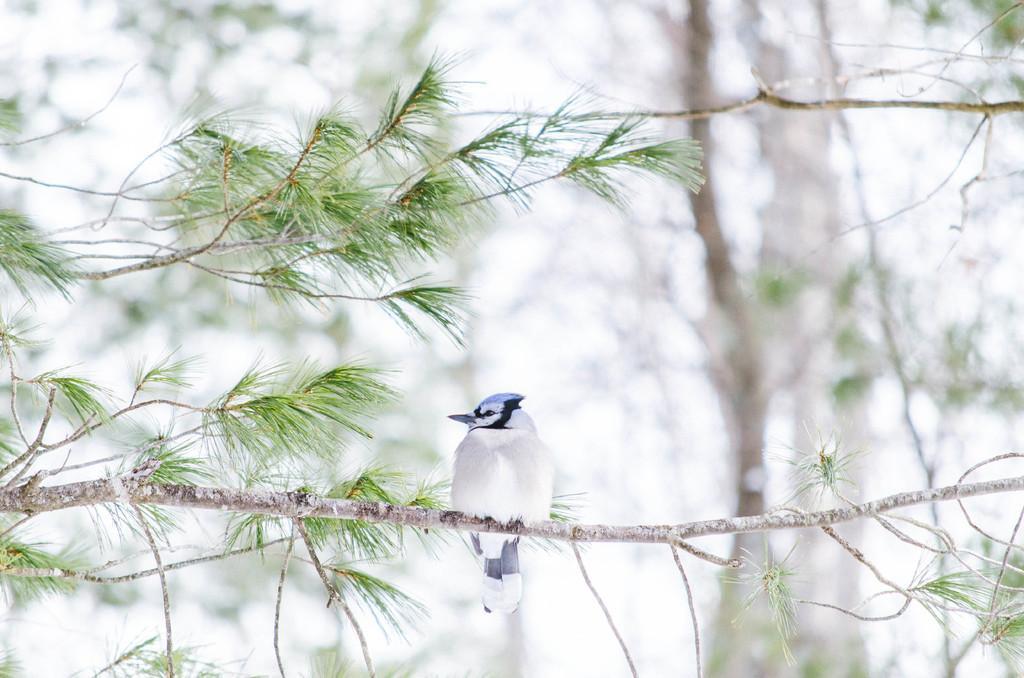Describe this image in one or two sentences. In the image we can see some trees, above the tree we can see a bird. 